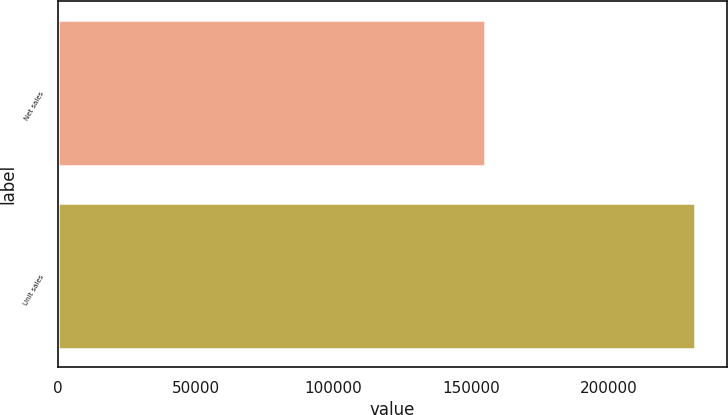Convert chart. <chart><loc_0><loc_0><loc_500><loc_500><bar_chart><fcel>Net sales<fcel>Unit sales<nl><fcel>155041<fcel>231218<nl></chart> 